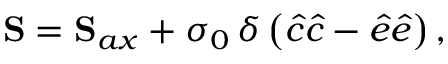Convert formula to latex. <formula><loc_0><loc_0><loc_500><loc_500>S = S _ { a x } + \sigma _ { 0 } \, \delta \left ( \hat { c } \hat { c } - \hat { e } \hat { e } \right ) ,</formula> 